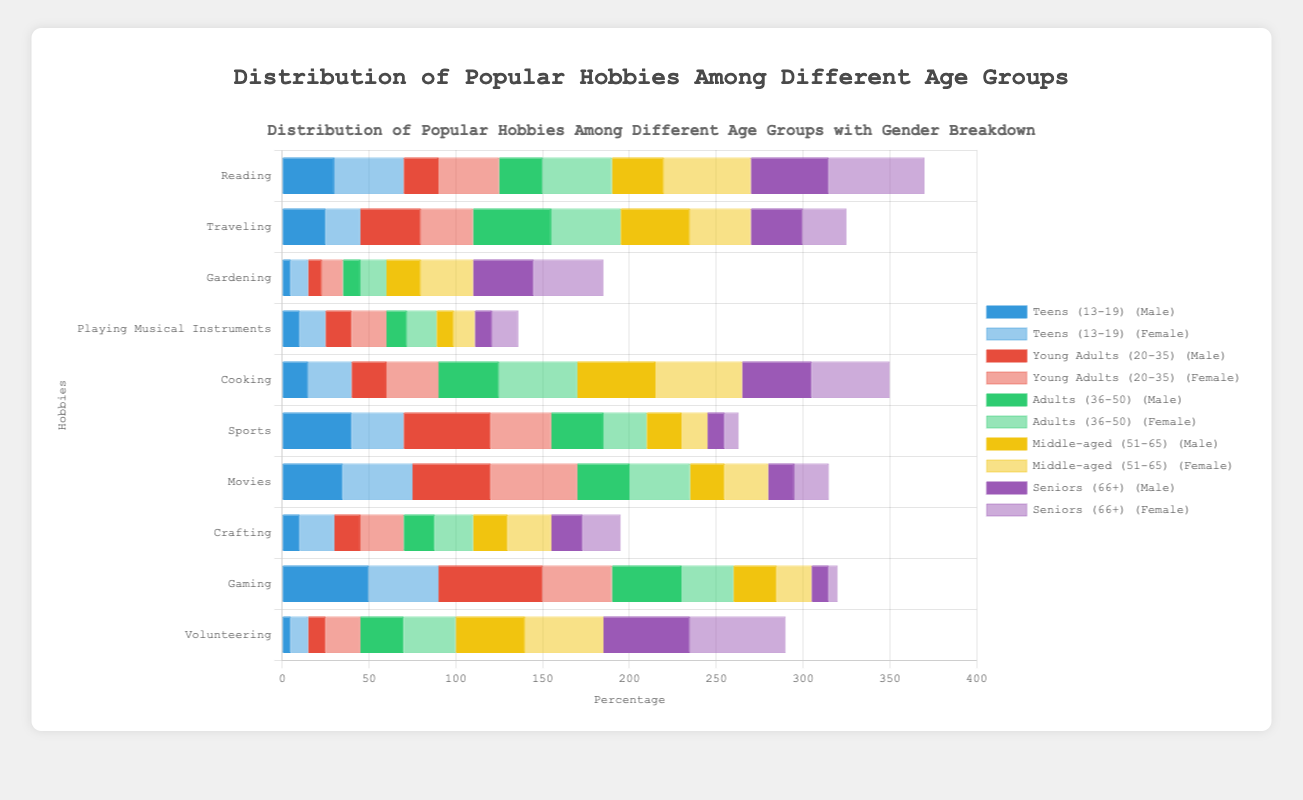Which hobby is the most popular among teens (13-19) for males and females? For teens, the highest values in the male and female bars are checked. The highest male value is 50% for Gaming, and the highest female value is 40% for both Reading and Movies.
Answer: Gaming (Males), Reading and Movies (Females) What is the least popular hobby for middle-aged (51-65) females? For middle-aged females, the smallest value in the female bar is identified, which is 15% for Sports.
Answer: Sports Which gender participates more in cooking among young adults (20-35)? Comparing the cooking values for young adult males and females, males have 20% while females have 30%. Thus, females participate more.
Answer: Females How does the popularity of volunteering compare between seniors (66+) and adults (36-50) for males? Volunteering is 50% for seniors males and 25% for adults males. Seniors males have a higher participation rate.
Answer: Seniors (66+) For seniors (66+), which hobby shows the largest gender difference in participation? The differences between male and female participation rates for each hobby are calculated. The largest difference is seen in Reading, with a difference of 10% (55-45).
Answer: Reading Which age group has the highest involvement in gaming? Comparing gaming values across all age groups, teens (13-19) males have the highest value at 50%.
Answer: Teens (13-19) What is the average popularity of playing musical instruments among all age groups for females? Summing up the values for playing musical instruments among females across all age groups: 15, 20, 17, 12, 15, and dividing by the number of age groups (5) gives: (15+20+17+12+15) / 5 = 15.8%
Answer: 15.8% Which hobby has an equal percentage of participation in any age group and gender? Checking for equal values within the same category, traveling for middle-aged (51-65) males and seniors (66+) females both have a participation rate of 25%.
Answer: Traveling among middle-aged males and senior females How do the participation rates in gardening differ between middle-aged (51-65) males and females? Middle-aged males have a 20% participation rate in gardening, while females have a 30% participation rate. Hence, females have a 10% higher participation.
Answer: Females by 10% 